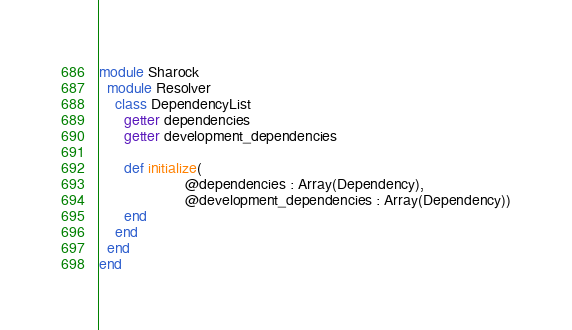Convert code to text. <code><loc_0><loc_0><loc_500><loc_500><_Crystal_>module Sharock
  module Resolver
    class DependencyList
      getter dependencies
      getter development_dependencies

      def initialize(
                     @dependencies : Array(Dependency),
                     @development_dependencies : Array(Dependency))
      end
    end
  end
end
</code> 